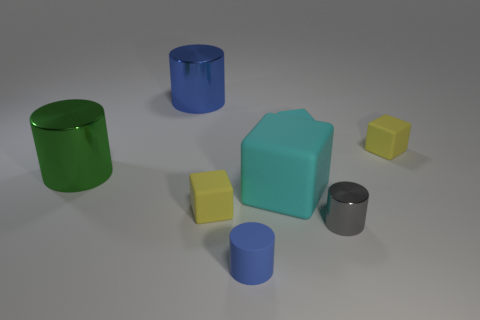Subtract all red blocks. Subtract all red balls. How many blocks are left? 4 Subtract all brown cylinders. How many purple blocks are left? 0 Add 7 large greens. How many objects exist? 0 Subtract all large cyan blocks. Subtract all large objects. How many objects are left? 4 Add 7 large green metallic cylinders. How many large green metallic cylinders are left? 8 Add 4 tiny cyan cubes. How many tiny cyan cubes exist? 5 Add 1 tiny purple objects. How many objects exist? 9 Subtract all cyan blocks. How many blocks are left? 2 Subtract all small cubes. How many cubes are left? 1 Subtract 0 purple balls. How many objects are left? 8 